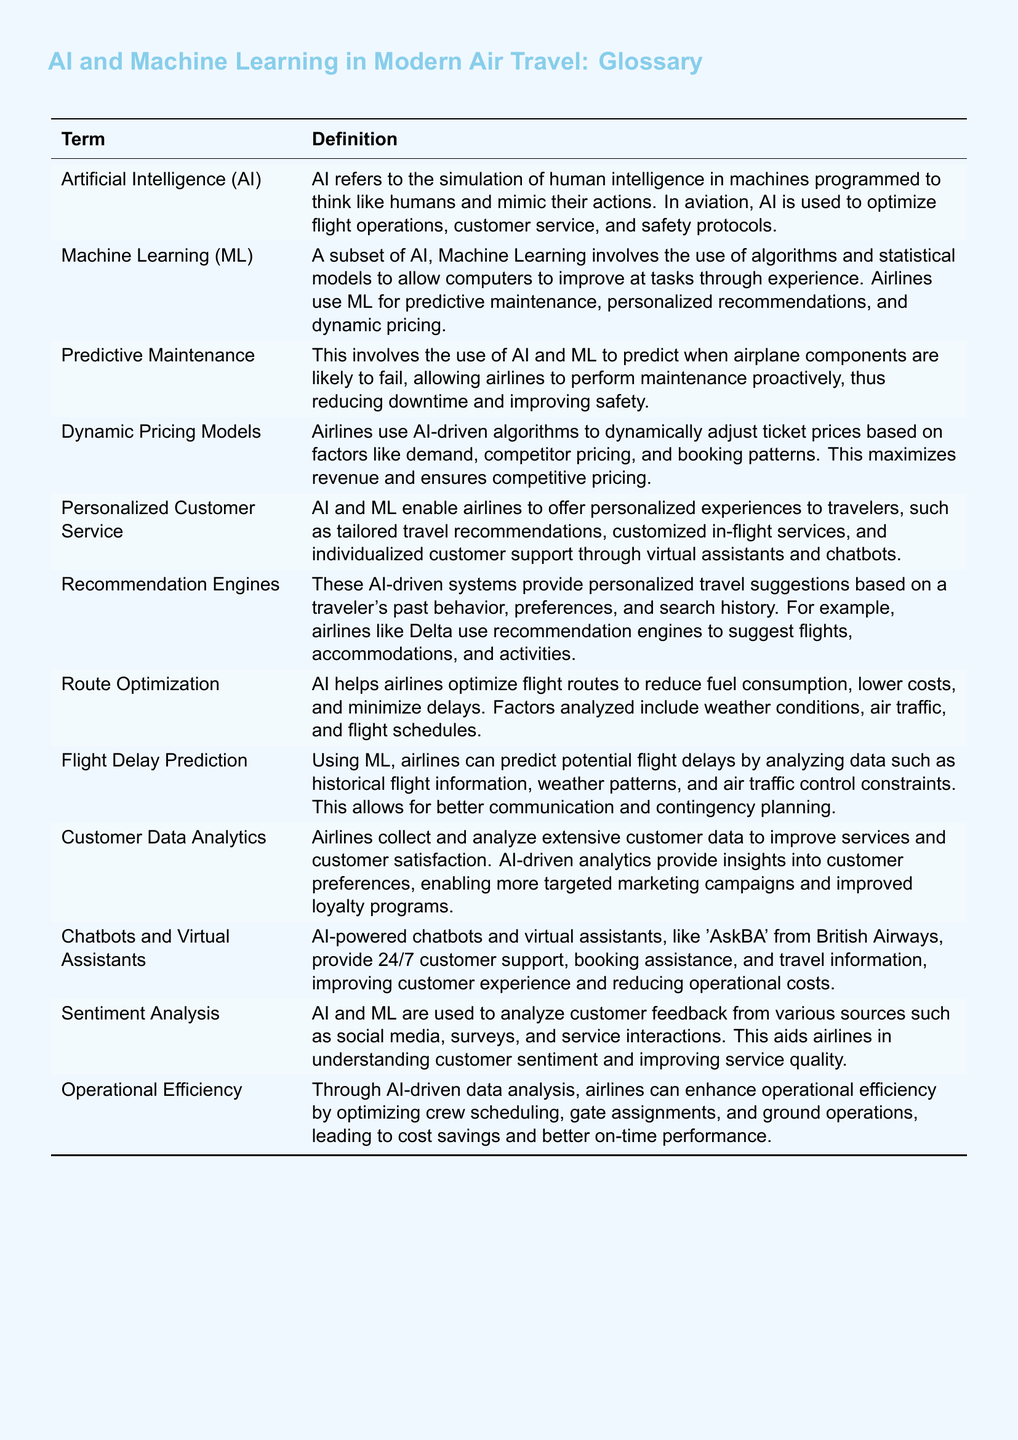what is the definition of Artificial Intelligence (AI)? The definition is provided in the glossary as a simulation of human intelligence in machines programmed to think like humans and mimic their actions.
Answer: simulation of human intelligence what is a subset of AI that involves algorithms improving from experience? The glossary defines this subset as a term specifically tied to AI, which is used in various applications by airlines.
Answer: Machine Learning (ML) how do airlines use AI for pricing? The document explains that AI-driven algorithms are employed for pricing strategies within the airline industry.
Answer: Dynamic Pricing Models what technique helps airlines minimize flight delays? The glossary suggests an analytical method involving data assessment to foresee potential flight issues.
Answer: Flight Delay Prediction which airline uses a system to suggest personalized travel recommendations? The example in the glossary provides the name of an airline that utilizes advanced technology for customer suggestions.
Answer: Delta what can sentiment analysis help airlines understand better? This analysis method is detailed in the glossary as vital for gaining insights into a particular aspect of customer feedback.
Answer: customer sentiment how do AI and ML enhance operational efficiency? The glossary mentions that airlines can improve several operational aspects through a specific type of analysis.
Answer: data analysis which technology provides 24/7 customer support according to the document? The glossary highlights a particular AI application that assists in customer service around the clock.
Answer: Chatbots and Virtual Assistants 